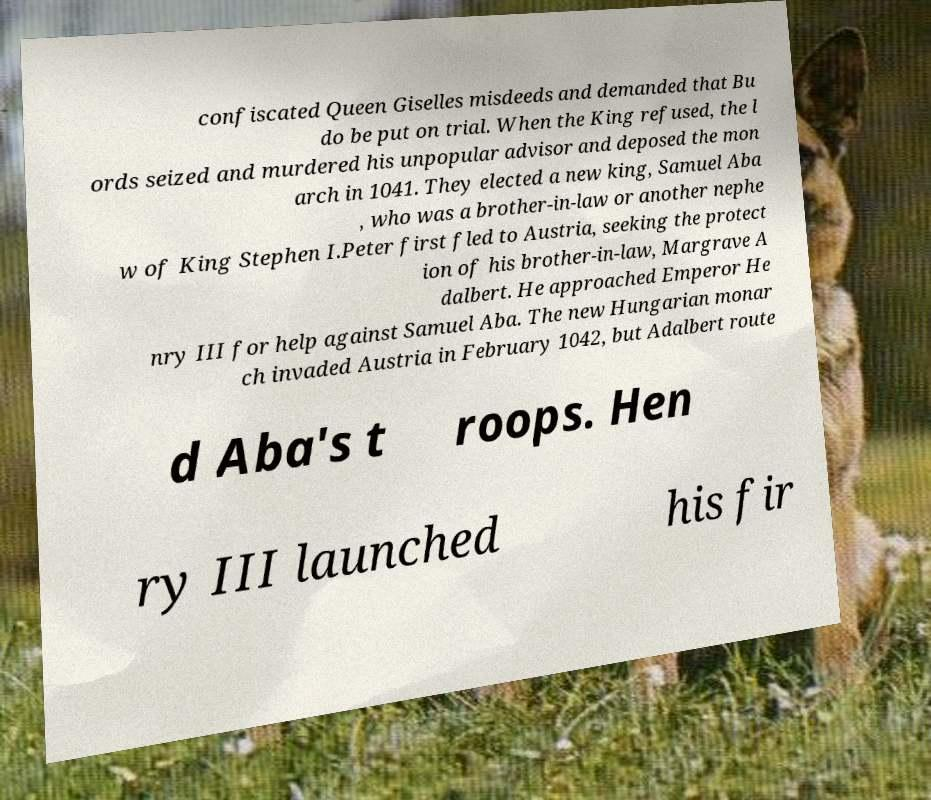Could you extract and type out the text from this image? confiscated Queen Giselles misdeeds and demanded that Bu do be put on trial. When the King refused, the l ords seized and murdered his unpopular advisor and deposed the mon arch in 1041. They elected a new king, Samuel Aba , who was a brother-in-law or another nephe w of King Stephen I.Peter first fled to Austria, seeking the protect ion of his brother-in-law, Margrave A dalbert. He approached Emperor He nry III for help against Samuel Aba. The new Hungarian monar ch invaded Austria in February 1042, but Adalbert route d Aba's t roops. Hen ry III launched his fir 